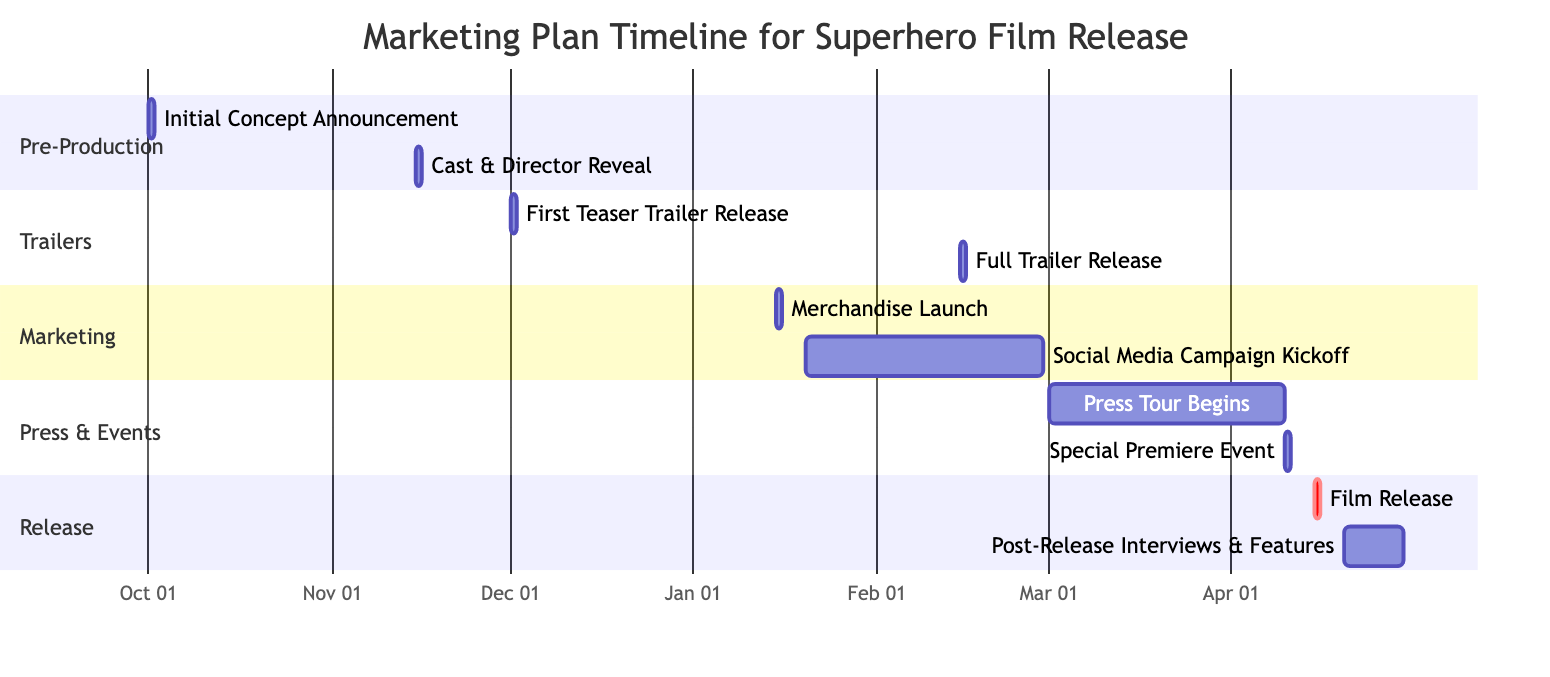What is the first activity listed in the timeline? The first activity in the timeline is "Initial Concept Announcement," which is indicated at the very beginning of the Gantt chart.
Answer: Initial Concept Announcement When is the "Full Trailer Release" scheduled? The Gantt chart shows that "Full Trailer Release" is scheduled for February 15, 2024, marked as a specific date under the Trailers section.
Answer: February 15, 2024 How many days is the "Social Media Campaign Kickoff" planned to last? "Social Media Campaign Kickoff" is scheduled to last for 40 days, as indicated next to the activity in the Marketing section of the Gantt chart.
Answer: 40 days What activity occurs directly before the "Film Release"? The activity that occurs directly before "Film Release" is "Special Premiere Event," which is set for April 10, 2024, exactly five days prior to the film release date.
Answer: Special Premiere Event Which section contains the "Cast & Director Reveal"? The "Cast & Director Reveal" is found in the Pre-Production section of the Gantt chart, grouping it with other initial promotional activities.
Answer: Pre-Production What is the relationship in timing between the "Merchandise Launch" and the "Social Media Campaign Kickoff"? The chart shows that "Merchandise Launch" occurs on January 15, 2024, and the "Social Media Campaign Kickoff" follows just five days later, beginning on January 20, 2024.
Answer: Five days apart What is the total number of activities listed in the timeline? By counting the activities visually represented in the Gantt chart, there are ten distinct activities listed throughout the different sections of the marketing plan.
Answer: Ten activities How long after the "Press Tour Begins" does the "Film Release" take place? "Press Tour Begins" starts on March 1, 2024, and the "Film Release" occurs on April 15, 2024, which shows there is a duration of 45 days between these two activities.
Answer: 45 days Which activity is classified as critical in the release section? The "Film Release" is classified as critical, as indicated by the 'crit' label in the Release section of the Gantt chart, highlighting its importance in the timeline.
Answer: Film Release 